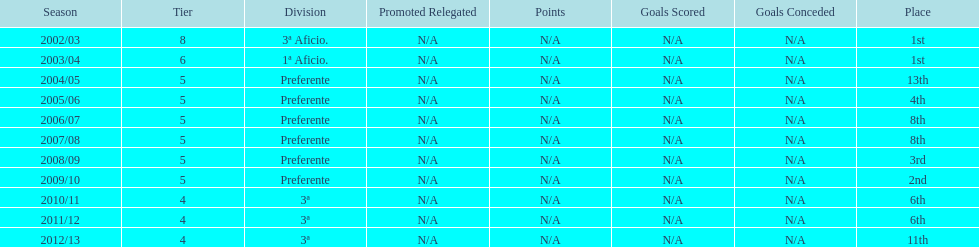How many times did internacional de madrid cf end the season at the top of their division? 2. 